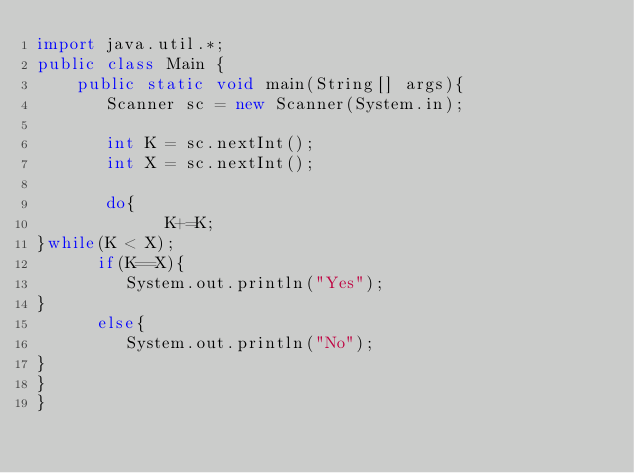Convert code to text. <code><loc_0><loc_0><loc_500><loc_500><_Java_>import java.util.*;
public class Main {
    public static void main(String[] args){
       Scanner sc = new Scanner(System.in);

       int K = sc.nextInt();
       int X = sc.nextInt();

       do{
             K+=K;
}while(K < X);
      if(K==X){
         System.out.println("Yes");
}
      else{
         System.out.println("No");
}
}
}
</code> 